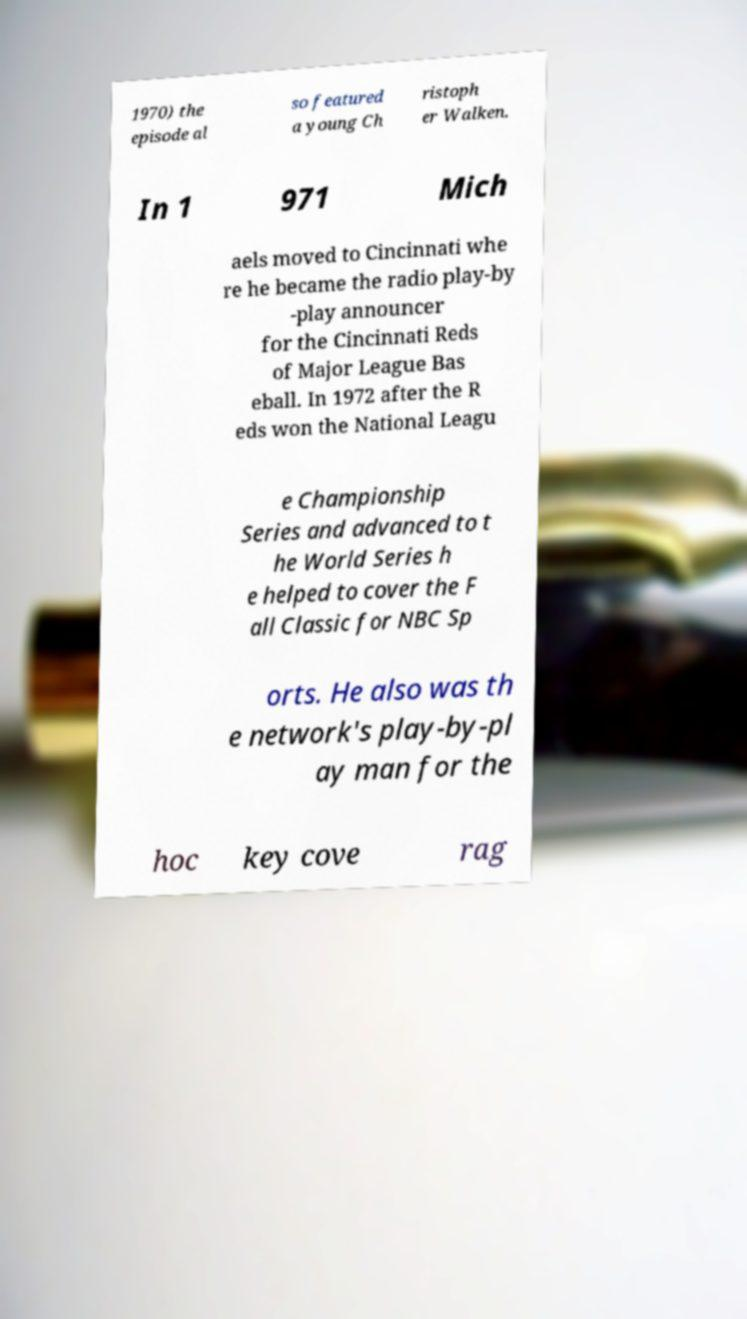Can you read and provide the text displayed in the image?This photo seems to have some interesting text. Can you extract and type it out for me? 1970) the episode al so featured a young Ch ristoph er Walken. In 1 971 Mich aels moved to Cincinnati whe re he became the radio play-by -play announcer for the Cincinnati Reds of Major League Bas eball. In 1972 after the R eds won the National Leagu e Championship Series and advanced to t he World Series h e helped to cover the F all Classic for NBC Sp orts. He also was th e network's play-by-pl ay man for the hoc key cove rag 